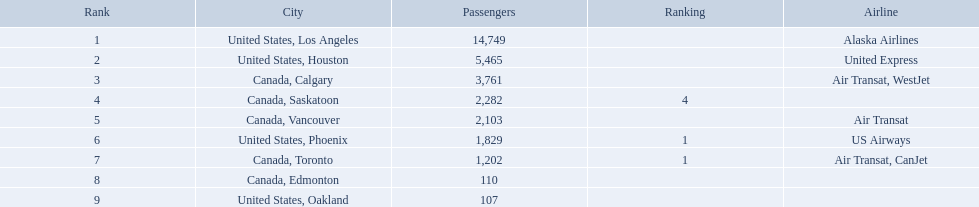What cities do the planes fly to? United States, Los Angeles, United States, Houston, Canada, Calgary, Canada, Saskatoon, Canada, Vancouver, United States, Phoenix, Canada, Toronto, Canada, Edmonton, United States, Oakland. How many people are flying to phoenix, arizona? 1,829. Which airport has the smallest number of passengers? 107. What airport has 107 passengers? United States, Oakland. Which places are connected by the airport? United States, Los Angeles, United States, Houston, Canada, Calgary, Canada, Saskatoon, Canada, Vancouver, United States, Phoenix, Canada, Toronto, Canada, Edmonton, United States, Oakland. Parse the table in full. {'header': ['Rank', 'City', 'Passengers', 'Ranking', 'Airline'], 'rows': [['1', 'United States, Los Angeles', '14,749', '', 'Alaska Airlines'], ['2', 'United States, Houston', '5,465', '', 'United Express'], ['3', 'Canada, Calgary', '3,761', '', 'Air Transat, WestJet'], ['4', 'Canada, Saskatoon', '2,282', '4', ''], ['5', 'Canada, Vancouver', '2,103', '', 'Air Transat'], ['6', 'United States, Phoenix', '1,829', '1', 'US Airways'], ['7', 'Canada, Toronto', '1,202', '1', 'Air Transat, CanJet'], ['8', 'Canada, Edmonton', '110', '', ''], ['9', 'United States, Oakland', '107', '', '']]} What is the quantity of passengers heading to phoenix? 1,829. Which cities had under 2,000 passengers? United States, Phoenix, Canada, Toronto, Canada, Edmonton, United States, Oakland. Of these cities, which had less than 1,000 passengers? Canada, Edmonton, United States, Oakland. Of the cities in the prior response, which one had only 107 passengers? United States, Oakland. Which urban centers do the aircraft travel to? United States, Los Angeles, United States, Houston, Canada, Calgary, Canada, Saskatoon, Canada, Vancouver, United States, Phoenix, Canada, Toronto, Canada, Edmonton, United States, Oakland. How many individuals are flying to phoenix, arizona? 1,829. At which airport can the smallest number of passengers be found? 107. Which airport accommodates 107 passengers? United States, Oakland. In which cities were there fewer than 2,000 passengers? United States, Phoenix, Canada, Toronto, Canada, Edmonton, United States, Oakland. Among them, which ones had less than 1,000 passengers? Canada, Edmonton, United States, Oakland. From the previously mentioned cities, which one had exactly 107 passengers? United States, Oakland. Which cities experienced a passenger count below 2,000? United States, Phoenix, Canada, Toronto, Canada, Edmonton, United States, Oakland. Out of these cities, which ones had under 1,000 passengers? Canada, Edmonton, United States, Oakland. From the cities in the prior response, which particular city had 107 passengers? United States, Oakland. What values are present in the column of passengers? 14,749, 5,465, 3,761, 2,282, 2,103, 1,829, 1,202, 110, 107. Which of these values is the smallest? 107. What is the city corresponding to this smallest value? United States, Oakland. What was the total number of passengers? 14,749, 5,465, 3,761, 2,282, 2,103, 1,829, 1,202, 110, 107. How many were heading to los angeles? 14,749. Which other destination, when combined with los angeles, comes closest to 19,000 passengers? Canada, Calgary. What was the overall passenger count? 14,749, 5,465, 3,761, 2,282, 2,103, 1,829, 1,202, 110, 107. What portion of these were going to los angeles? 14,749. When added to another destination, which combination approaches 19,000 passengers the most? Canada, Calgary. What are the cities linked to playa de oro international airport? United States, Los Angeles, United States, Houston, Canada, Calgary, Canada, Saskatoon, Canada, Vancouver, United States, Phoenix, Canada, Toronto, Canada, Edmonton, United States, Oakland. Can you parse all the data within this table? {'header': ['Rank', 'City', 'Passengers', 'Ranking', 'Airline'], 'rows': [['1', 'United States, Los Angeles', '14,749', '', 'Alaska Airlines'], ['2', 'United States, Houston', '5,465', '', 'United Express'], ['3', 'Canada, Calgary', '3,761', '', 'Air Transat, WestJet'], ['4', 'Canada, Saskatoon', '2,282', '4', ''], ['5', 'Canada, Vancouver', '2,103', '', 'Air Transat'], ['6', 'United States, Phoenix', '1,829', '1', 'US Airways'], ['7', 'Canada, Toronto', '1,202', '1', 'Air Transat, CanJet'], ['8', 'Canada, Edmonton', '110', '', ''], ['9', 'United States, Oakland', '107', '', '']]} How many passengers are there from los angeles, usa? 14,749. What additional cities would result in a total passenger count of around 19,000 when combined with los angeles? Canada, Calgary. Which cities have a connection to playa de oro international airport? United States, Los Angeles, United States, Houston, Canada, Calgary, Canada, Saskatoon, Canada, Vancouver, United States, Phoenix, Canada, Toronto, Canada, Edmonton, United States, Oakland. What is the number of passengers from los angeles in the united states? 14,749. Which other cities' passenger counts would sum up to roughly 19,000 when added to los angeles' count? Canada, Calgary. To what urban centers do the airplanes go? United States, Los Angeles, United States, Houston, Canada, Calgary, Canada, Saskatoon, Canada, Vancouver, United States, Phoenix, Canada, Toronto, Canada, Edmonton, United States, Oakland. How many individuals are en route to phoenix, arizona? 1,829. I'm looking to parse the entire table for insights. Could you assist me with that? {'header': ['Rank', 'City', 'Passengers', 'Ranking', 'Airline'], 'rows': [['1', 'United States, Los Angeles', '14,749', '', 'Alaska Airlines'], ['2', 'United States, Houston', '5,465', '', 'United Express'], ['3', 'Canada, Calgary', '3,761', '', 'Air Transat, WestJet'], ['4', 'Canada, Saskatoon', '2,282', '4', ''], ['5', 'Canada, Vancouver', '2,103', '', 'Air Transat'], ['6', 'United States, Phoenix', '1,829', '1', 'US Airways'], ['7', 'Canada, Toronto', '1,202', '1', 'Air Transat, CanJet'], ['8', 'Canada, Edmonton', '110', '', ''], ['9', 'United States, Oakland', '107', '', '']]} Which cities are included in the flight destinations? United States, Los Angeles, United States, Houston, Canada, Calgary, Canada, Saskatoon, Canada, Vancouver, United States, Phoenix, Canada, Toronto, Canada, Edmonton, United States, Oakland. How many passengers were there in phoenix? 1,829. To which cities do the flights go? United States, Los Angeles, United States, Houston, Canada, Calgary, Canada, Saskatoon, Canada, Vancouver, United States, Phoenix, Canada, Toronto, Canada, Edmonton, United States, Oakland. What was the passenger count for phoenix? 1,829. What destinations do the flights cover? United States, Los Angeles, United States, Houston, Canada, Calgary, Canada, Saskatoon, Canada, Vancouver, United States, Phoenix, Canada, Toronto, Canada, Edmonton, United States, Oakland. How many people flew to phoenix? 1,829. What are the airport's target destinations? United States, Los Angeles, United States, Houston, Canada, Calgary, Canada, Saskatoon, Canada, Vancouver, United States, Phoenix, Canada, Toronto, Canada, Edmonton, United States, Oakland. How many passengers are traveling to phoenix? 1,829. 